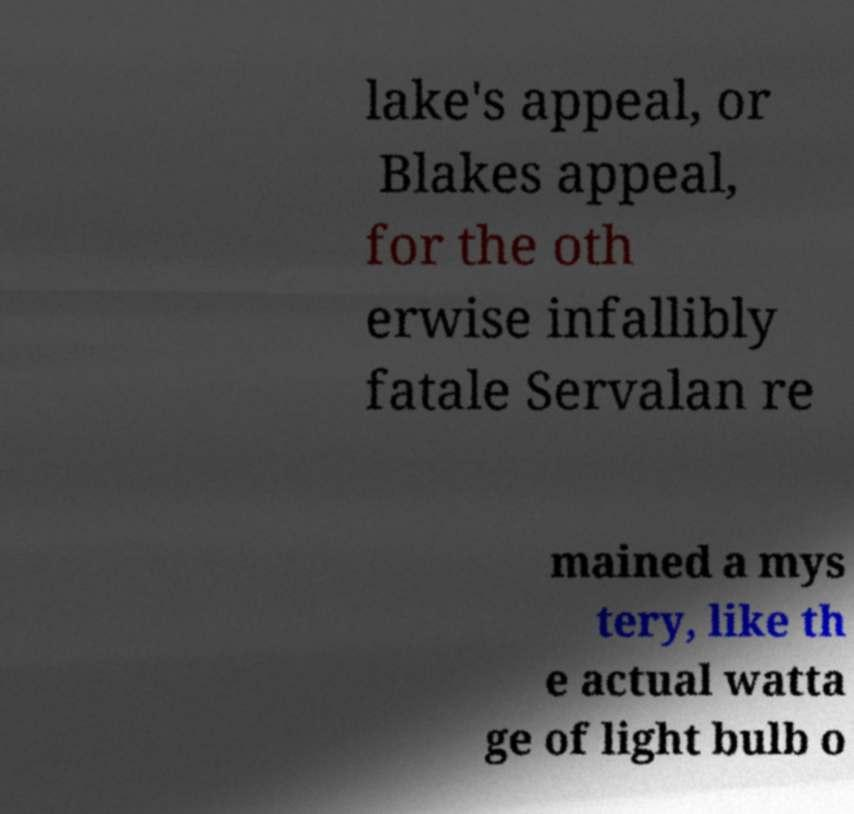What messages or text are displayed in this image? I need them in a readable, typed format. lake's appeal, or Blakes appeal, for the oth erwise infallibly fatale Servalan re mained a mys tery, like th e actual watta ge of light bulb o 